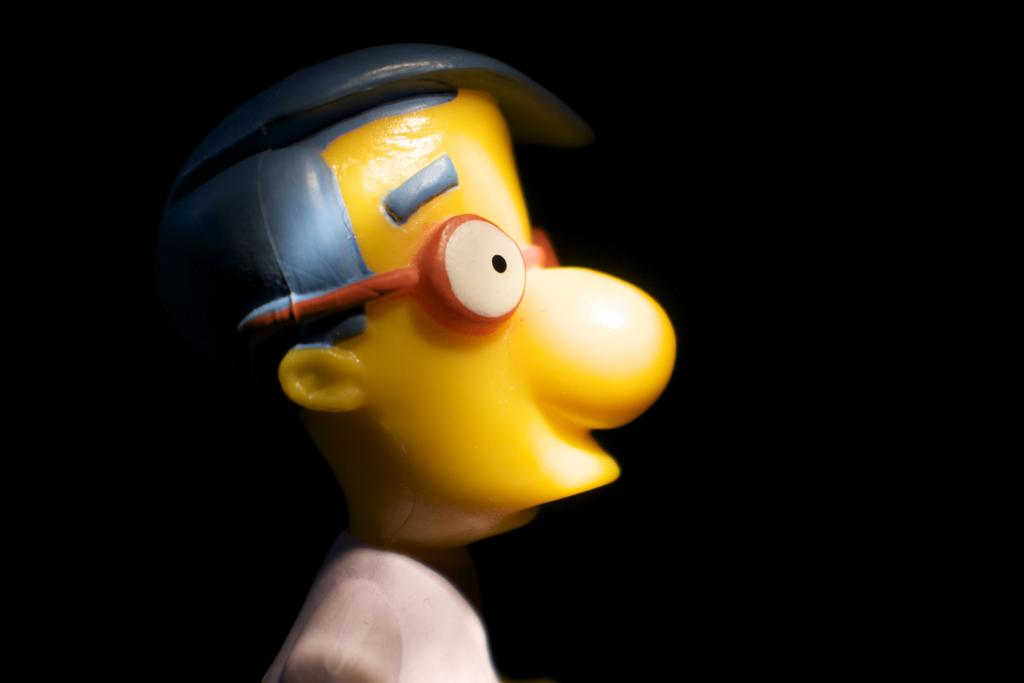What type of object in the image resembles a person? There is a toy in the image that looks like a person. What can be observed about the background of the image? The background of the image is dark. What type of plantation is visible in the image? There is no plantation present in the image. How are the giants interacting with the toy in the image? There are no giants present in the image. 